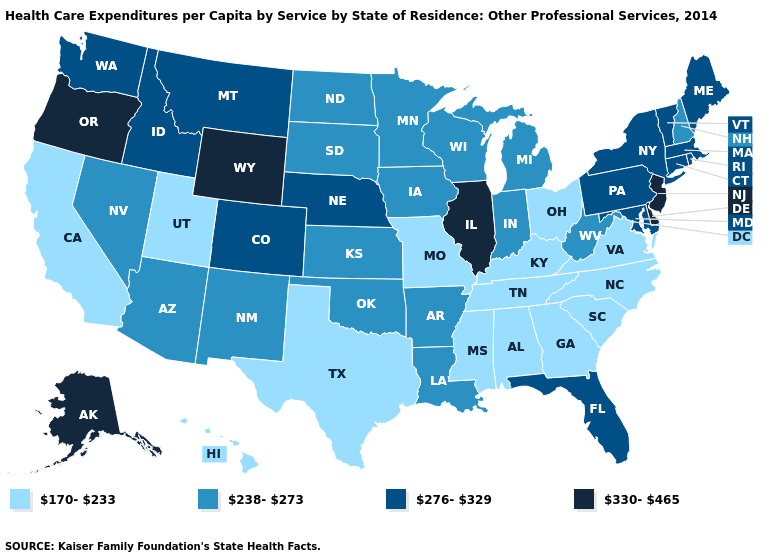Name the states that have a value in the range 330-465?
Give a very brief answer. Alaska, Delaware, Illinois, New Jersey, Oregon, Wyoming. Name the states that have a value in the range 238-273?
Be succinct. Arizona, Arkansas, Indiana, Iowa, Kansas, Louisiana, Michigan, Minnesota, Nevada, New Hampshire, New Mexico, North Dakota, Oklahoma, South Dakota, West Virginia, Wisconsin. How many symbols are there in the legend?
Answer briefly. 4. Does Colorado have the highest value in the West?
Concise answer only. No. Name the states that have a value in the range 238-273?
Be succinct. Arizona, Arkansas, Indiana, Iowa, Kansas, Louisiana, Michigan, Minnesota, Nevada, New Hampshire, New Mexico, North Dakota, Oklahoma, South Dakota, West Virginia, Wisconsin. What is the value of Kentucky?
Concise answer only. 170-233. Name the states that have a value in the range 330-465?
Be succinct. Alaska, Delaware, Illinois, New Jersey, Oregon, Wyoming. What is the highest value in the USA?
Keep it brief. 330-465. Name the states that have a value in the range 330-465?
Quick response, please. Alaska, Delaware, Illinois, New Jersey, Oregon, Wyoming. What is the highest value in the USA?
Answer briefly. 330-465. What is the highest value in the USA?
Be succinct. 330-465. What is the value of Maine?
Answer briefly. 276-329. Among the states that border Georgia , which have the highest value?
Short answer required. Florida. Among the states that border New York , does New Jersey have the lowest value?
Write a very short answer. No. Name the states that have a value in the range 170-233?
Be succinct. Alabama, California, Georgia, Hawaii, Kentucky, Mississippi, Missouri, North Carolina, Ohio, South Carolina, Tennessee, Texas, Utah, Virginia. 